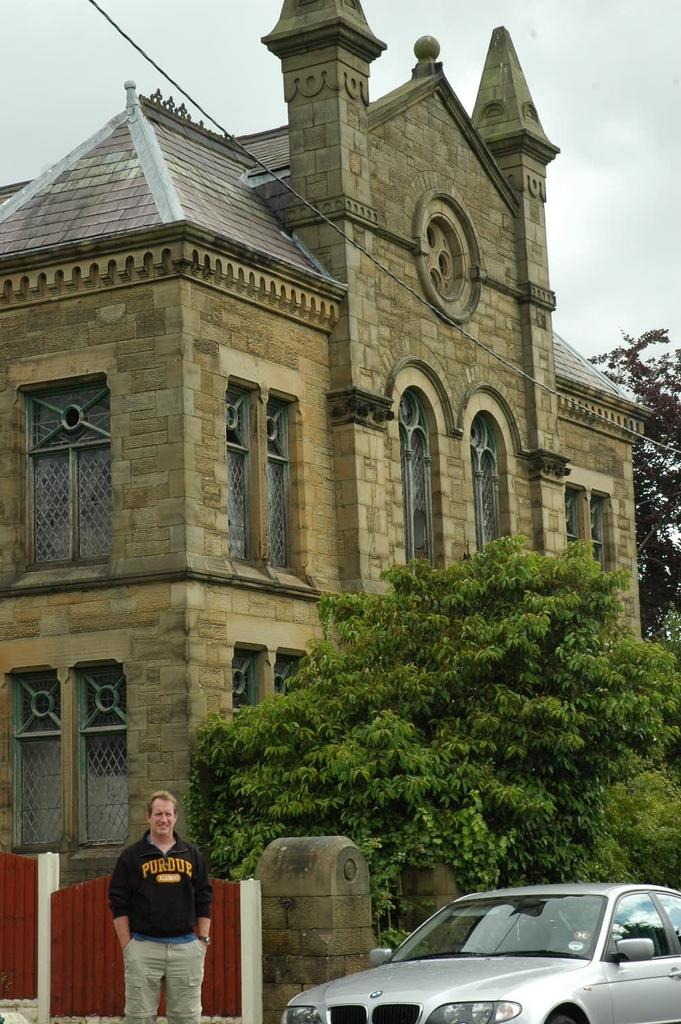What type of structure is visible in the image? There is a building in the image. What can be seen in front of the building? There are trees and a car in front of the building. Can you describe the man's position in the image? The man is on the left side of the image. What else can be seen in the background of the image? There is a tree in the background of the image. What type of powder is being used by the army in the image? There is no army or powder present in the image. How many feet can be seen in the image? There is no reference to feet in the image, so it is not possible to answer that question. 